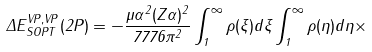<formula> <loc_0><loc_0><loc_500><loc_500>\Delta E ^ { V P , V P } _ { S O P T } ( 2 P ) = - \frac { \mu \alpha ^ { 2 } ( Z \alpha ) ^ { 2 } } { 7 7 7 6 \pi ^ { 2 } } \int _ { 1 } ^ { \infty } \rho ( \xi ) d \xi \int _ { 1 } ^ { \infty } \rho ( \eta ) d \eta \times</formula> 